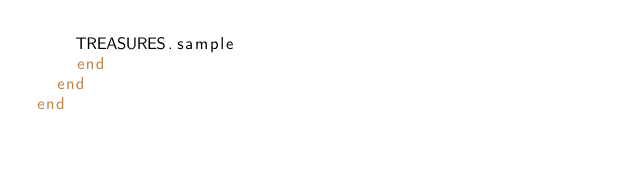Convert code to text. <code><loc_0><loc_0><loc_500><loc_500><_Ruby_>    TREASURES.sample
    end
  end
end</code> 